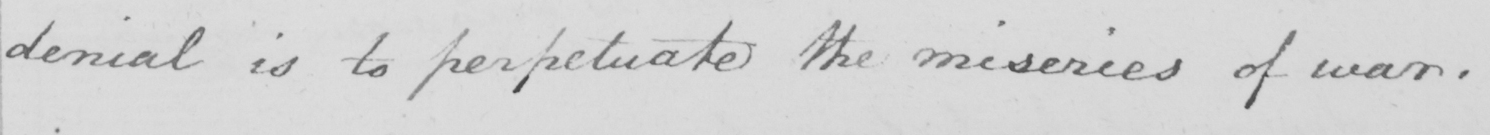Can you tell me what this handwritten text says? denial is to perpetuate the miseries of war . 